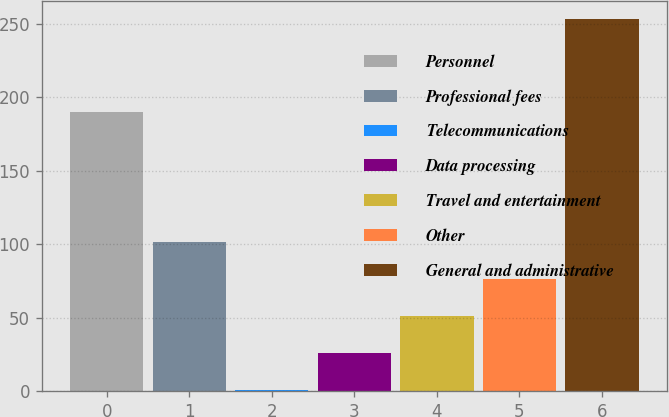Convert chart to OTSL. <chart><loc_0><loc_0><loc_500><loc_500><bar_chart><fcel>Personnel<fcel>Professional fees<fcel>Telecommunications<fcel>Data processing<fcel>Travel and entertainment<fcel>Other<fcel>General and administrative<nl><fcel>190<fcel>101.8<fcel>1<fcel>26.2<fcel>51.4<fcel>76.6<fcel>253<nl></chart> 